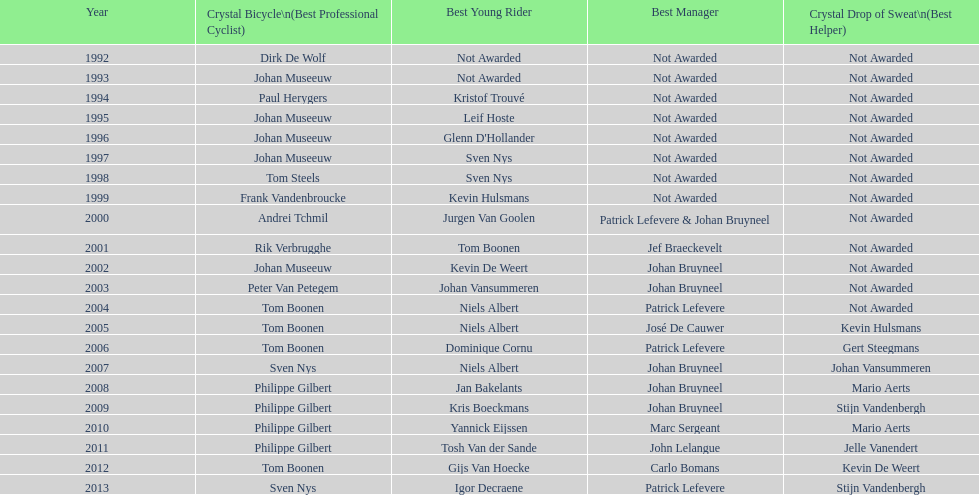Who holds the record for the most uninterrupted triumphs in crystal bicycle competitions? Philippe Gilbert. 